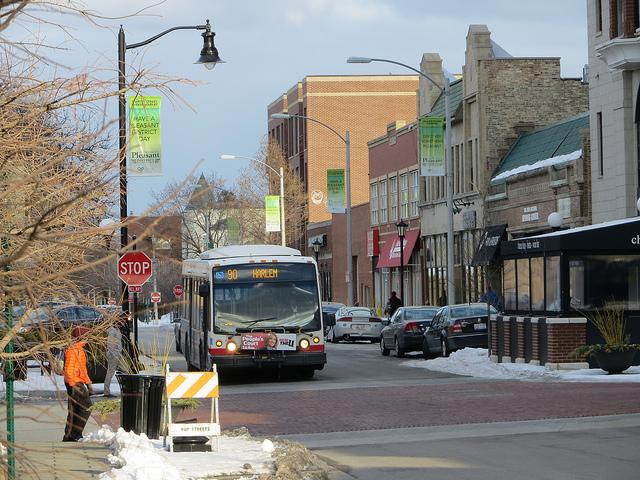Where is the bus headed to? Please explain your reasoning. harlem. The bus goes to harlem. 